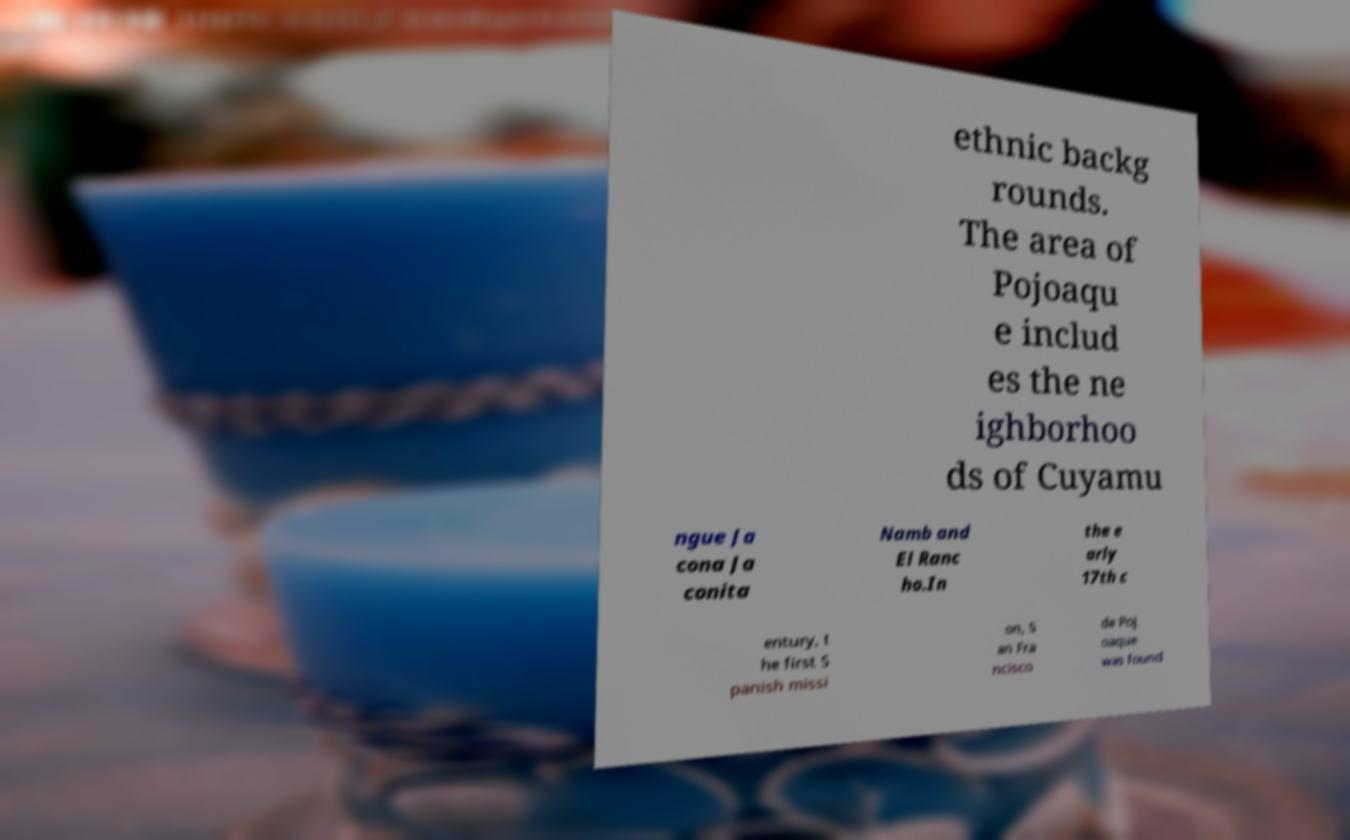What messages or text are displayed in this image? I need them in a readable, typed format. ethnic backg rounds. The area of Pojoaqu e includ es the ne ighborhoo ds of Cuyamu ngue Ja cona Ja conita Namb and El Ranc ho.In the e arly 17th c entury, t he first S panish missi on, S an Fra ncisco de Poj oaque was found 